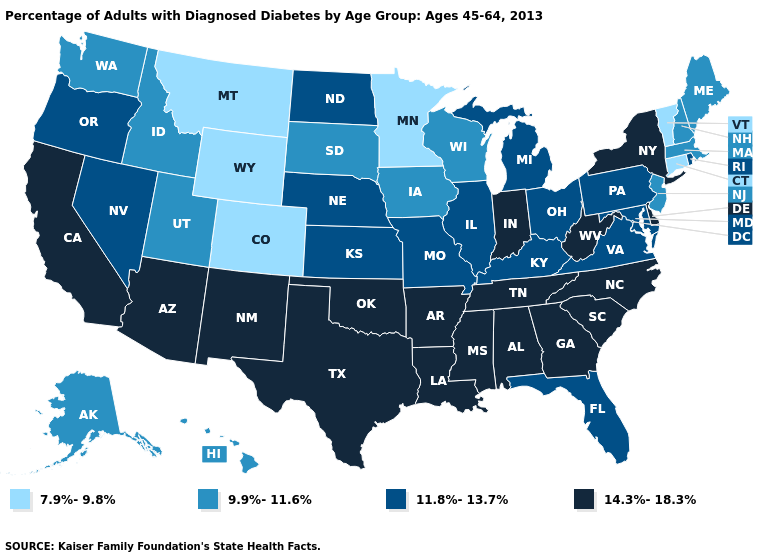What is the value of West Virginia?
Be succinct. 14.3%-18.3%. Among the states that border South Dakota , which have the highest value?
Quick response, please. Nebraska, North Dakota. Name the states that have a value in the range 7.9%-9.8%?
Keep it brief. Colorado, Connecticut, Minnesota, Montana, Vermont, Wyoming. Does the map have missing data?
Answer briefly. No. Does Florida have the highest value in the South?
Concise answer only. No. Does West Virginia have a lower value than Colorado?
Short answer required. No. What is the value of New Jersey?
Concise answer only. 9.9%-11.6%. What is the lowest value in the USA?
Answer briefly. 7.9%-9.8%. Does Wyoming have the lowest value in the West?
Quick response, please. Yes. Does Utah have a lower value than Michigan?
Answer briefly. Yes. What is the lowest value in the South?
Short answer required. 11.8%-13.7%. Does West Virginia have the highest value in the South?
Short answer required. Yes. Does North Carolina have the lowest value in the South?
Be succinct. No. Does the map have missing data?
Keep it brief. No. 